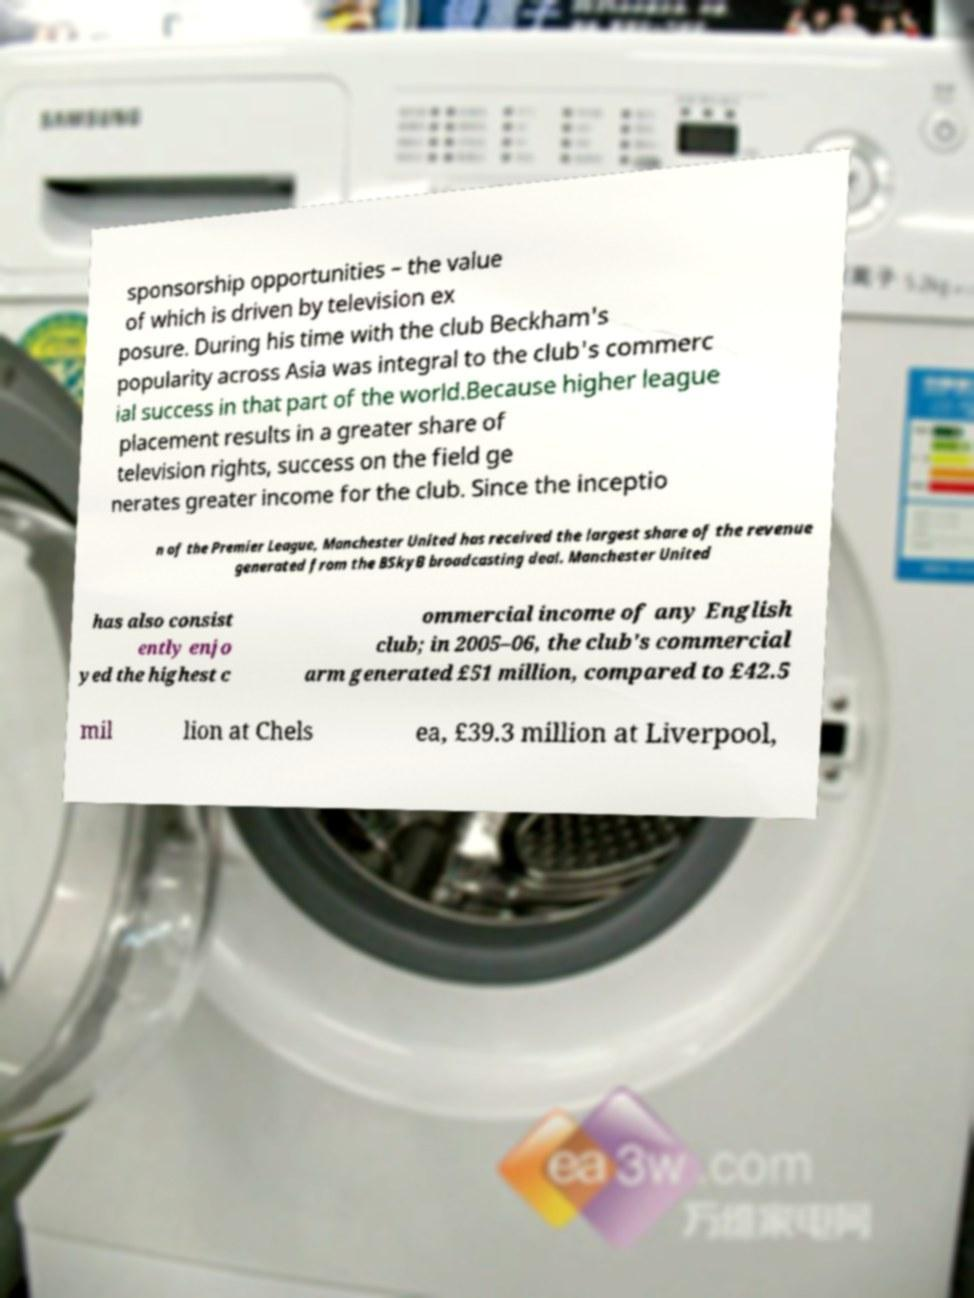Could you assist in decoding the text presented in this image and type it out clearly? sponsorship opportunities – the value of which is driven by television ex posure. During his time with the club Beckham's popularity across Asia was integral to the club's commerc ial success in that part of the world.Because higher league placement results in a greater share of television rights, success on the field ge nerates greater income for the club. Since the inceptio n of the Premier League, Manchester United has received the largest share of the revenue generated from the BSkyB broadcasting deal. Manchester United has also consist ently enjo yed the highest c ommercial income of any English club; in 2005–06, the club's commercial arm generated £51 million, compared to £42.5 mil lion at Chels ea, £39.3 million at Liverpool, 